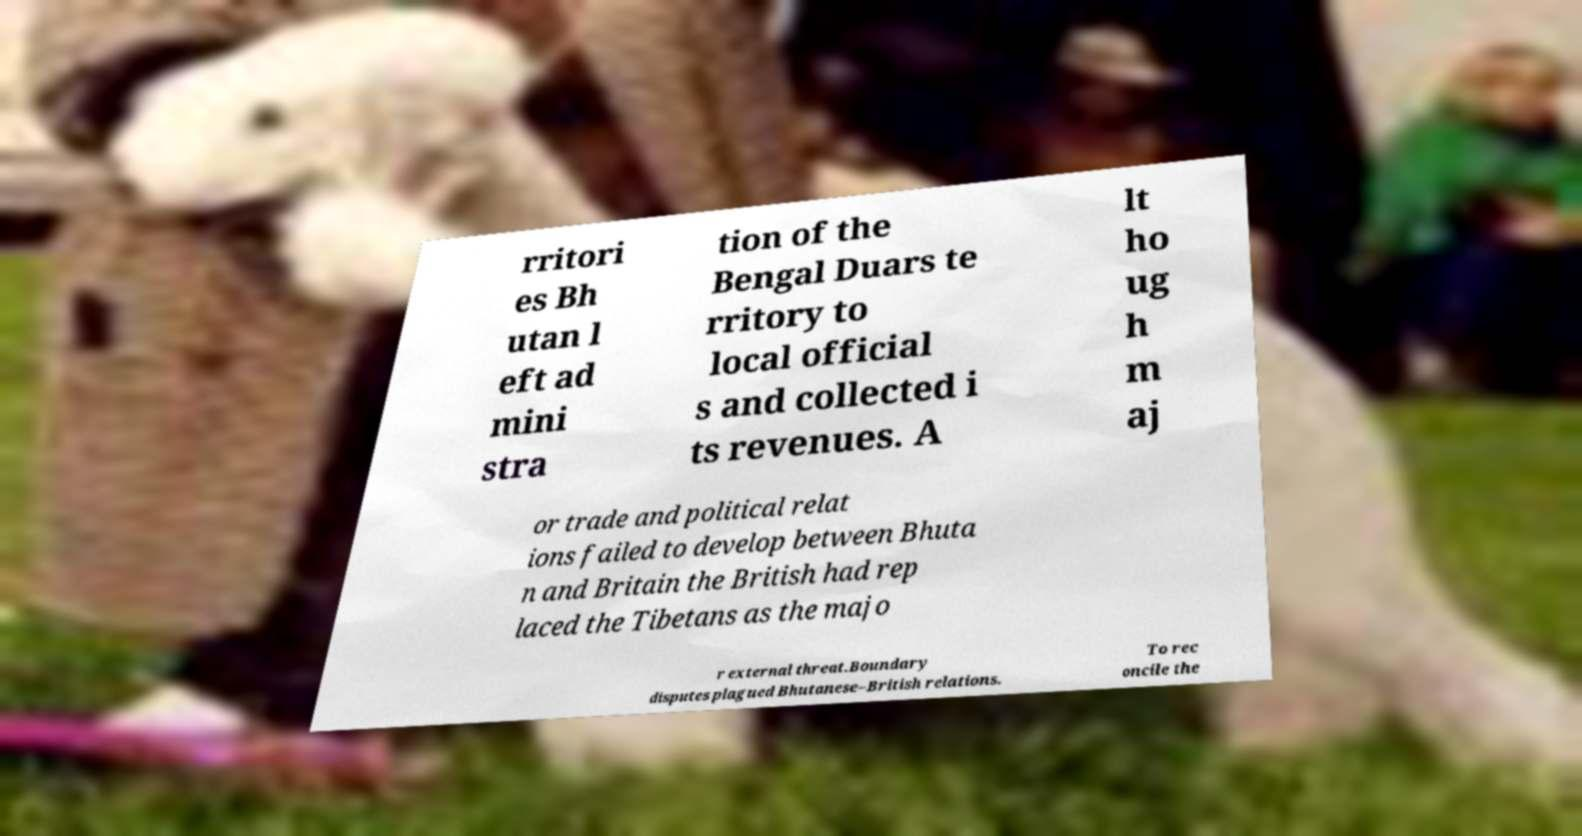Can you read and provide the text displayed in the image?This photo seems to have some interesting text. Can you extract and type it out for me? rritori es Bh utan l eft ad mini stra tion of the Bengal Duars te rritory to local official s and collected i ts revenues. A lt ho ug h m aj or trade and political relat ions failed to develop between Bhuta n and Britain the British had rep laced the Tibetans as the majo r external threat.Boundary disputes plagued Bhutanese–British relations. To rec oncile the 